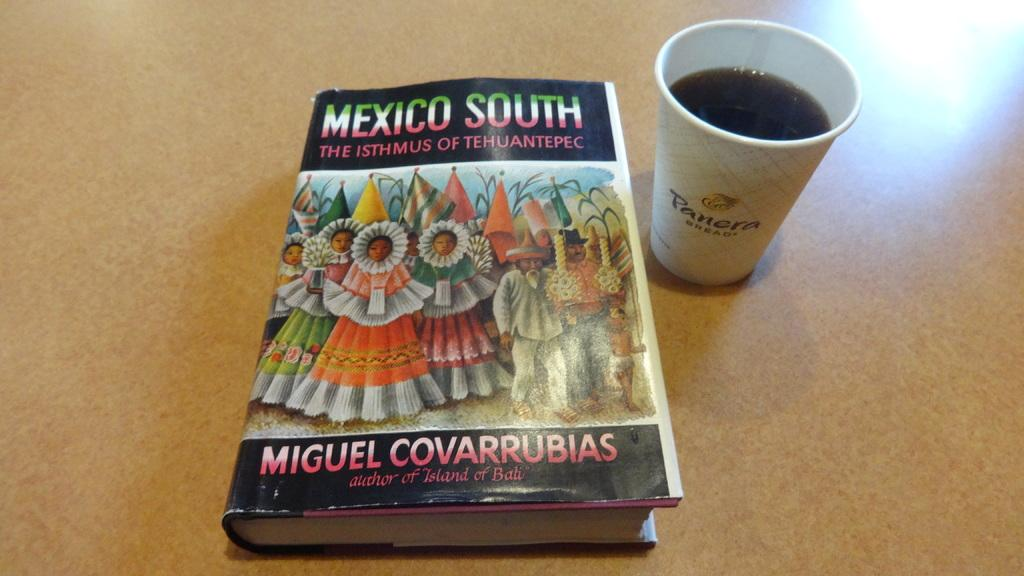What object can be seen in the image that is typically used for reading? There is a book in the image that is typically used for reading. What is depicted on the book? There is a picture of some people on the book. What is another object visible in the image? There is a cup in the image. What type of pie is being served on the book in the image? There is no pie present in the image; it features a book with a picture of some people. What valuable jewel can be seen on the tongue of the person in the image? There is no jewel or person present in the image; it only features a book and a cup. 